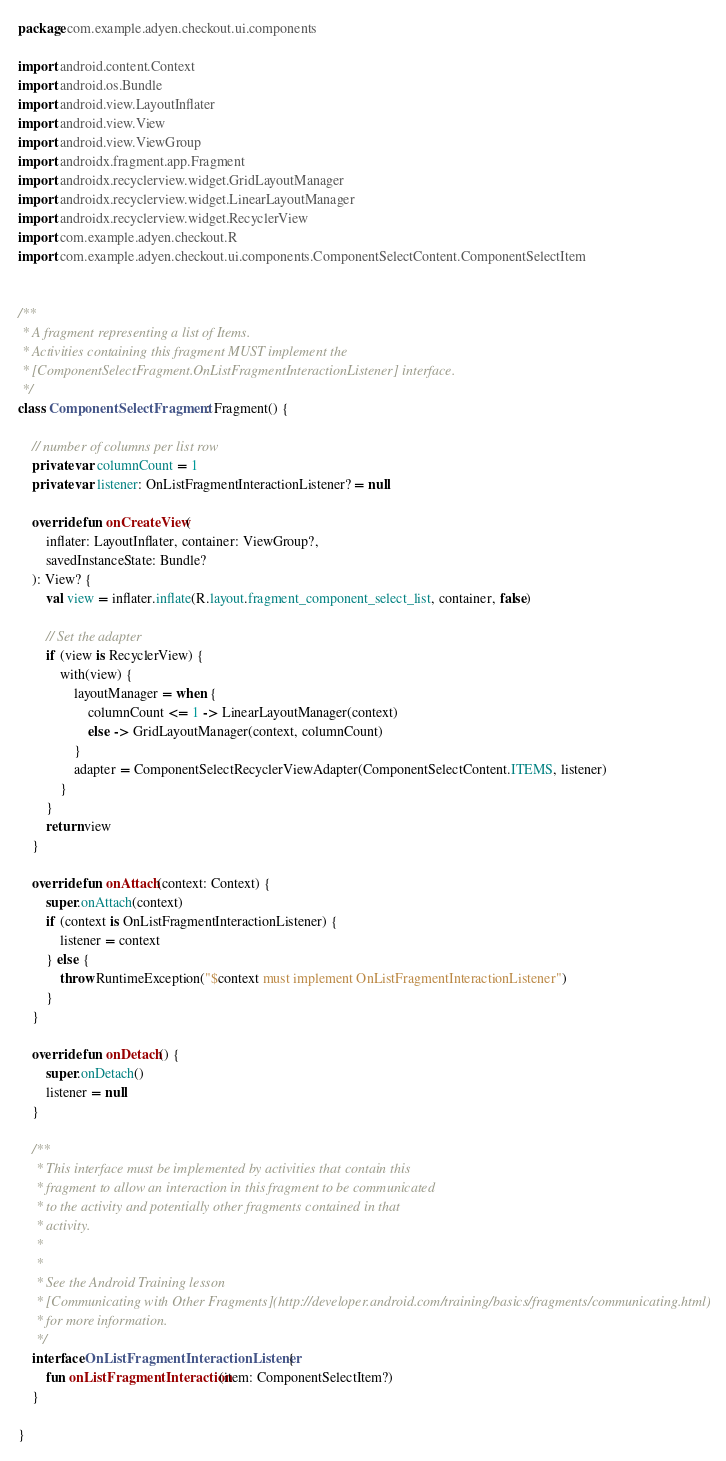<code> <loc_0><loc_0><loc_500><loc_500><_Kotlin_>package com.example.adyen.checkout.ui.components

import android.content.Context
import android.os.Bundle
import android.view.LayoutInflater
import android.view.View
import android.view.ViewGroup
import androidx.fragment.app.Fragment
import androidx.recyclerview.widget.GridLayoutManager
import androidx.recyclerview.widget.LinearLayoutManager
import androidx.recyclerview.widget.RecyclerView
import com.example.adyen.checkout.R
import com.example.adyen.checkout.ui.components.ComponentSelectContent.ComponentSelectItem


/**
 * A fragment representing a list of Items.
 * Activities containing this fragment MUST implement the
 * [ComponentSelectFragment.OnListFragmentInteractionListener] interface.
 */
class ComponentSelectFragment : Fragment() {

    // number of columns per list row
    private var columnCount = 1
    private var listener: OnListFragmentInteractionListener? = null

    override fun onCreateView(
        inflater: LayoutInflater, container: ViewGroup?,
        savedInstanceState: Bundle?
    ): View? {
        val view = inflater.inflate(R.layout.fragment_component_select_list, container, false)

        // Set the adapter
        if (view is RecyclerView) {
            with(view) {
                layoutManager = when {
                    columnCount <= 1 -> LinearLayoutManager(context)
                    else -> GridLayoutManager(context, columnCount)
                }
                adapter = ComponentSelectRecyclerViewAdapter(ComponentSelectContent.ITEMS, listener)
            }
        }
        return view
    }

    override fun onAttach(context: Context) {
        super.onAttach(context)
        if (context is OnListFragmentInteractionListener) {
            listener = context
        } else {
            throw RuntimeException("$context must implement OnListFragmentInteractionListener")
        }
    }

    override fun onDetach() {
        super.onDetach()
        listener = null
    }

    /**
     * This interface must be implemented by activities that contain this
     * fragment to allow an interaction in this fragment to be communicated
     * to the activity and potentially other fragments contained in that
     * activity.
     *
     *
     * See the Android Training lesson
     * [Communicating with Other Fragments](http://developer.android.com/training/basics/fragments/communicating.html)
     * for more information.
     */
    interface OnListFragmentInteractionListener {
        fun onListFragmentInteraction(item: ComponentSelectItem?)
    }

}
</code> 